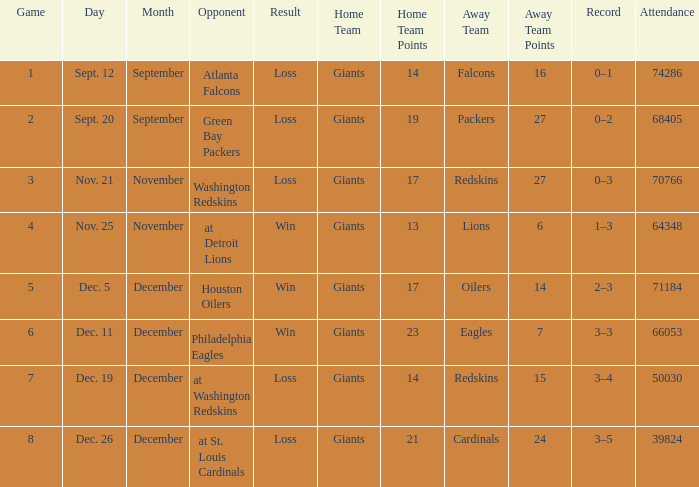What is the record when the opponent is washington redskins? 0–3. 